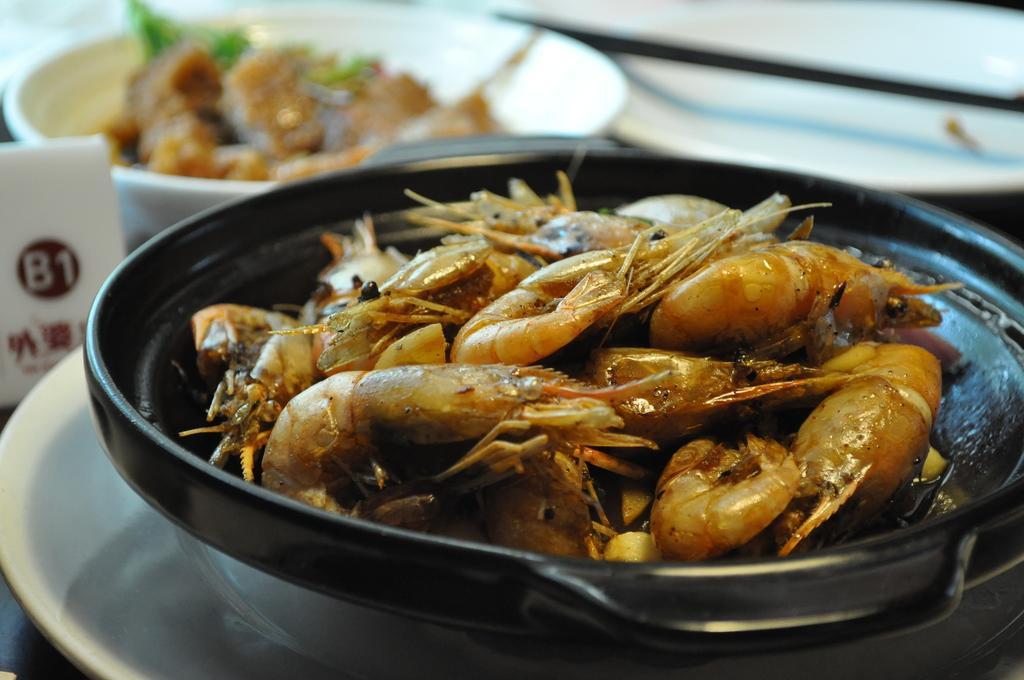Can you describe this image briefly? In this picture there is a plate in the center of the image, which contains cuisine in it and there is a bowl at the top side of the image. 